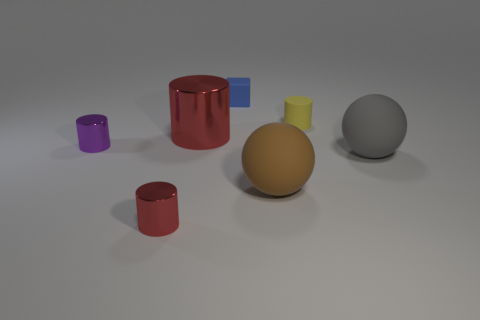What is the size of the brown rubber object that is the same shape as the large gray rubber object?
Keep it short and to the point. Large. There is a large cylinder; is its color the same as the tiny shiny object that is in front of the large gray thing?
Make the answer very short. Yes. Are there any red objects that have the same size as the purple metal cylinder?
Keep it short and to the point. Yes. How many objects are either red cylinders or tiny cyan rubber cubes?
Ensure brevity in your answer.  2. Does the metal cylinder that is on the left side of the tiny red metallic object have the same size as the red metal thing behind the small red shiny cylinder?
Provide a succinct answer. No. Is there a small brown thing of the same shape as the large red metal object?
Ensure brevity in your answer.  No. Are there fewer brown balls behind the small purple metal cylinder than tiny objects?
Keep it short and to the point. Yes. Is the large brown object the same shape as the gray matte object?
Make the answer very short. Yes. How big is the thing that is behind the tiny yellow cylinder?
Provide a succinct answer. Small. What size is the block that is the same material as the brown ball?
Provide a succinct answer. Small. 